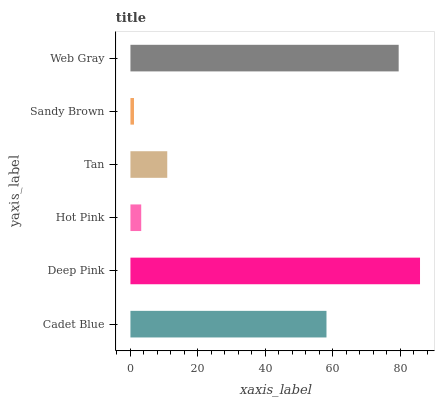Is Sandy Brown the minimum?
Answer yes or no. Yes. Is Deep Pink the maximum?
Answer yes or no. Yes. Is Hot Pink the minimum?
Answer yes or no. No. Is Hot Pink the maximum?
Answer yes or no. No. Is Deep Pink greater than Hot Pink?
Answer yes or no. Yes. Is Hot Pink less than Deep Pink?
Answer yes or no. Yes. Is Hot Pink greater than Deep Pink?
Answer yes or no. No. Is Deep Pink less than Hot Pink?
Answer yes or no. No. Is Cadet Blue the high median?
Answer yes or no. Yes. Is Tan the low median?
Answer yes or no. Yes. Is Hot Pink the high median?
Answer yes or no. No. Is Deep Pink the low median?
Answer yes or no. No. 